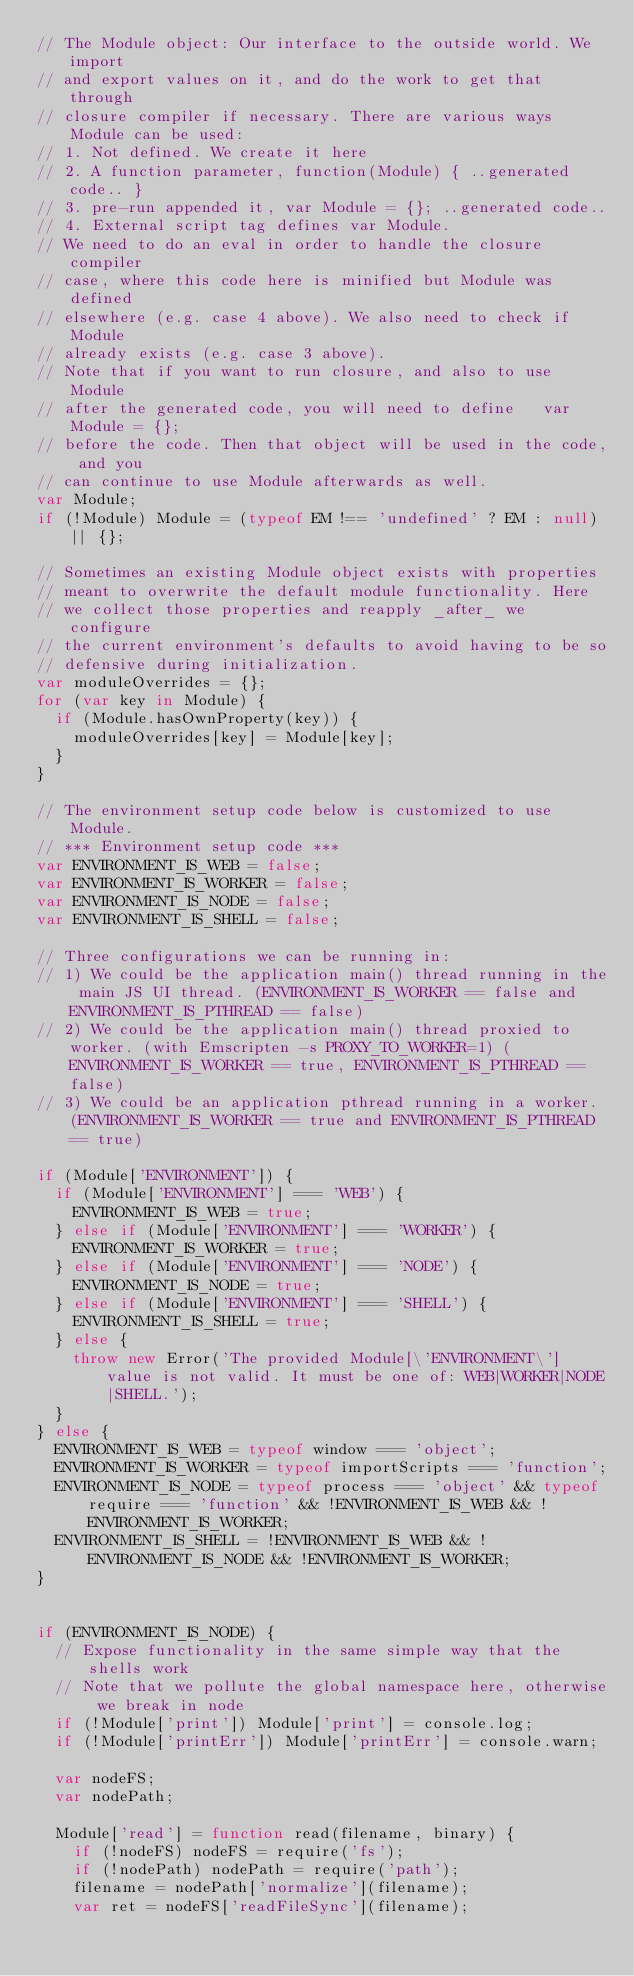Convert code to text. <code><loc_0><loc_0><loc_500><loc_500><_JavaScript_>// The Module object: Our interface to the outside world. We import
// and export values on it, and do the work to get that through
// closure compiler if necessary. There are various ways Module can be used:
// 1. Not defined. We create it here
// 2. A function parameter, function(Module) { ..generated code.. }
// 3. pre-run appended it, var Module = {}; ..generated code..
// 4. External script tag defines var Module.
// We need to do an eval in order to handle the closure compiler
// case, where this code here is minified but Module was defined
// elsewhere (e.g. case 4 above). We also need to check if Module
// already exists (e.g. case 3 above).
// Note that if you want to run closure, and also to use Module
// after the generated code, you will need to define   var Module = {};
// before the code. Then that object will be used in the code, and you
// can continue to use Module afterwards as well.
var Module;
if (!Module) Module = (typeof EM !== 'undefined' ? EM : null) || {};

// Sometimes an existing Module object exists with properties
// meant to overwrite the default module functionality. Here
// we collect those properties and reapply _after_ we configure
// the current environment's defaults to avoid having to be so
// defensive during initialization.
var moduleOverrides = {};
for (var key in Module) {
  if (Module.hasOwnProperty(key)) {
    moduleOverrides[key] = Module[key];
  }
}

// The environment setup code below is customized to use Module.
// *** Environment setup code ***
var ENVIRONMENT_IS_WEB = false;
var ENVIRONMENT_IS_WORKER = false;
var ENVIRONMENT_IS_NODE = false;
var ENVIRONMENT_IS_SHELL = false;

// Three configurations we can be running in:
// 1) We could be the application main() thread running in the main JS UI thread. (ENVIRONMENT_IS_WORKER == false and ENVIRONMENT_IS_PTHREAD == false)
// 2) We could be the application main() thread proxied to worker. (with Emscripten -s PROXY_TO_WORKER=1) (ENVIRONMENT_IS_WORKER == true, ENVIRONMENT_IS_PTHREAD == false)
// 3) We could be an application pthread running in a worker. (ENVIRONMENT_IS_WORKER == true and ENVIRONMENT_IS_PTHREAD == true)

if (Module['ENVIRONMENT']) {
  if (Module['ENVIRONMENT'] === 'WEB') {
    ENVIRONMENT_IS_WEB = true;
  } else if (Module['ENVIRONMENT'] === 'WORKER') {
    ENVIRONMENT_IS_WORKER = true;
  } else if (Module['ENVIRONMENT'] === 'NODE') {
    ENVIRONMENT_IS_NODE = true;
  } else if (Module['ENVIRONMENT'] === 'SHELL') {
    ENVIRONMENT_IS_SHELL = true;
  } else {
    throw new Error('The provided Module[\'ENVIRONMENT\'] value is not valid. It must be one of: WEB|WORKER|NODE|SHELL.');
  }
} else {
  ENVIRONMENT_IS_WEB = typeof window === 'object';
  ENVIRONMENT_IS_WORKER = typeof importScripts === 'function';
  ENVIRONMENT_IS_NODE = typeof process === 'object' && typeof require === 'function' && !ENVIRONMENT_IS_WEB && !ENVIRONMENT_IS_WORKER;
  ENVIRONMENT_IS_SHELL = !ENVIRONMENT_IS_WEB && !ENVIRONMENT_IS_NODE && !ENVIRONMENT_IS_WORKER;
}


if (ENVIRONMENT_IS_NODE) {
  // Expose functionality in the same simple way that the shells work
  // Note that we pollute the global namespace here, otherwise we break in node
  if (!Module['print']) Module['print'] = console.log;
  if (!Module['printErr']) Module['printErr'] = console.warn;

  var nodeFS;
  var nodePath;

  Module['read'] = function read(filename, binary) {
    if (!nodeFS) nodeFS = require('fs');
    if (!nodePath) nodePath = require('path');
    filename = nodePath['normalize'](filename);
    var ret = nodeFS['readFileSync'](filename);</code> 